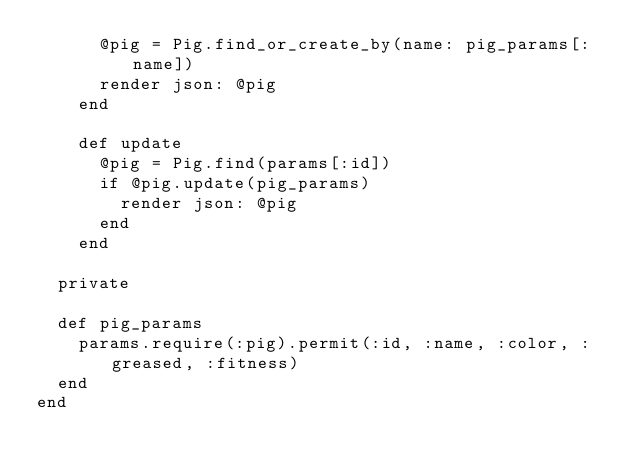Convert code to text. <code><loc_0><loc_0><loc_500><loc_500><_Ruby_>      @pig = Pig.find_or_create_by(name: pig_params[:name])
      render json: @pig
    end

    def update
      @pig = Pig.find(params[:id])
      if @pig.update(pig_params)
        render json: @pig
      end
    end

  private

  def pig_params
    params.require(:pig).permit(:id, :name, :color, :greased, :fitness)
  end
end
</code> 